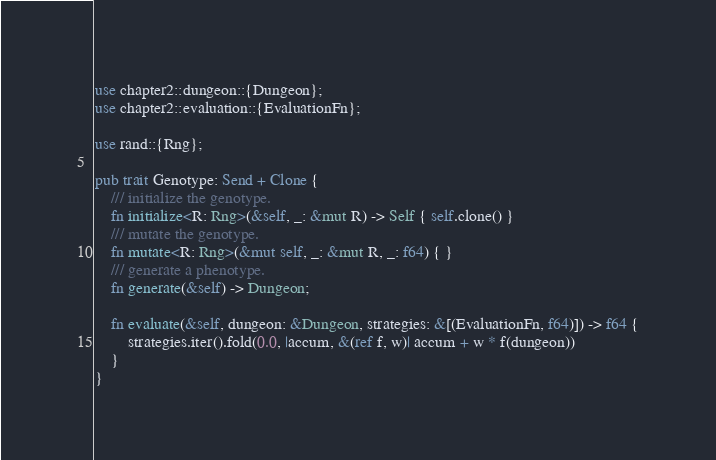<code> <loc_0><loc_0><loc_500><loc_500><_Rust_>use chapter2::dungeon::{Dungeon};
use chapter2::evaluation::{EvaluationFn};

use rand::{Rng};

pub trait Genotype: Send + Clone {
    /// initialize the genotype.
    fn initialize<R: Rng>(&self, _: &mut R) -> Self { self.clone() }
    /// mutate the genotype.
    fn mutate<R: Rng>(&mut self, _: &mut R, _: f64) { }
    /// generate a phenotype.
    fn generate(&self) -> Dungeon;

    fn evaluate(&self, dungeon: &Dungeon, strategies: &[(EvaluationFn, f64)]) -> f64 {
        strategies.iter().fold(0.0, |accum, &(ref f, w)| accum + w * f(dungeon))
    }
}
</code> 